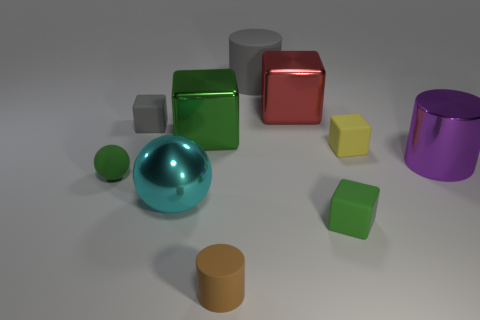Subtract all large purple cylinders. How many cylinders are left? 2 Subtract all green spheres. How many spheres are left? 1 Subtract all red cubes. How many gray cylinders are left? 1 Subtract 0 blue blocks. How many objects are left? 10 Subtract all balls. How many objects are left? 8 Subtract 2 cylinders. How many cylinders are left? 1 Subtract all gray spheres. Subtract all gray blocks. How many spheres are left? 2 Subtract all large cyan spheres. Subtract all purple metal cylinders. How many objects are left? 8 Add 6 tiny gray blocks. How many tiny gray blocks are left? 7 Add 4 large cyan objects. How many large cyan objects exist? 5 